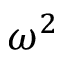Convert formula to latex. <formula><loc_0><loc_0><loc_500><loc_500>\omega ^ { 2 }</formula> 